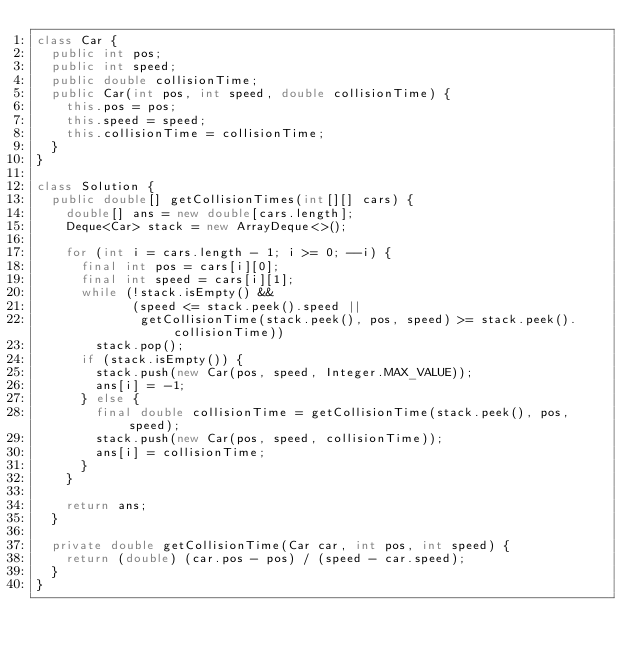Convert code to text. <code><loc_0><loc_0><loc_500><loc_500><_Java_>class Car {
  public int pos;
  public int speed;
  public double collisionTime;
  public Car(int pos, int speed, double collisionTime) {
    this.pos = pos;
    this.speed = speed;
    this.collisionTime = collisionTime;
  }
}

class Solution {
  public double[] getCollisionTimes(int[][] cars) {
    double[] ans = new double[cars.length];
    Deque<Car> stack = new ArrayDeque<>();

    for (int i = cars.length - 1; i >= 0; --i) {
      final int pos = cars[i][0];
      final int speed = cars[i][1];
      while (!stack.isEmpty() &&
             (speed <= stack.peek().speed ||
              getCollisionTime(stack.peek(), pos, speed) >= stack.peek().collisionTime))
        stack.pop();
      if (stack.isEmpty()) {
        stack.push(new Car(pos, speed, Integer.MAX_VALUE));
        ans[i] = -1;
      } else {
        final double collisionTime = getCollisionTime(stack.peek(), pos, speed);
        stack.push(new Car(pos, speed, collisionTime));
        ans[i] = collisionTime;
      }
    }

    return ans;
  }

  private double getCollisionTime(Car car, int pos, int speed) {
    return (double) (car.pos - pos) / (speed - car.speed);
  }
}
</code> 